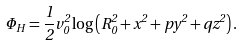Convert formula to latex. <formula><loc_0><loc_0><loc_500><loc_500>\Phi _ { H } = \frac { 1 } { 2 } v ^ { 2 } _ { 0 } \log \left ( R ^ { 2 } _ { 0 } + x ^ { 2 } + p y ^ { 2 } + q z ^ { 2 } \right ) .</formula> 